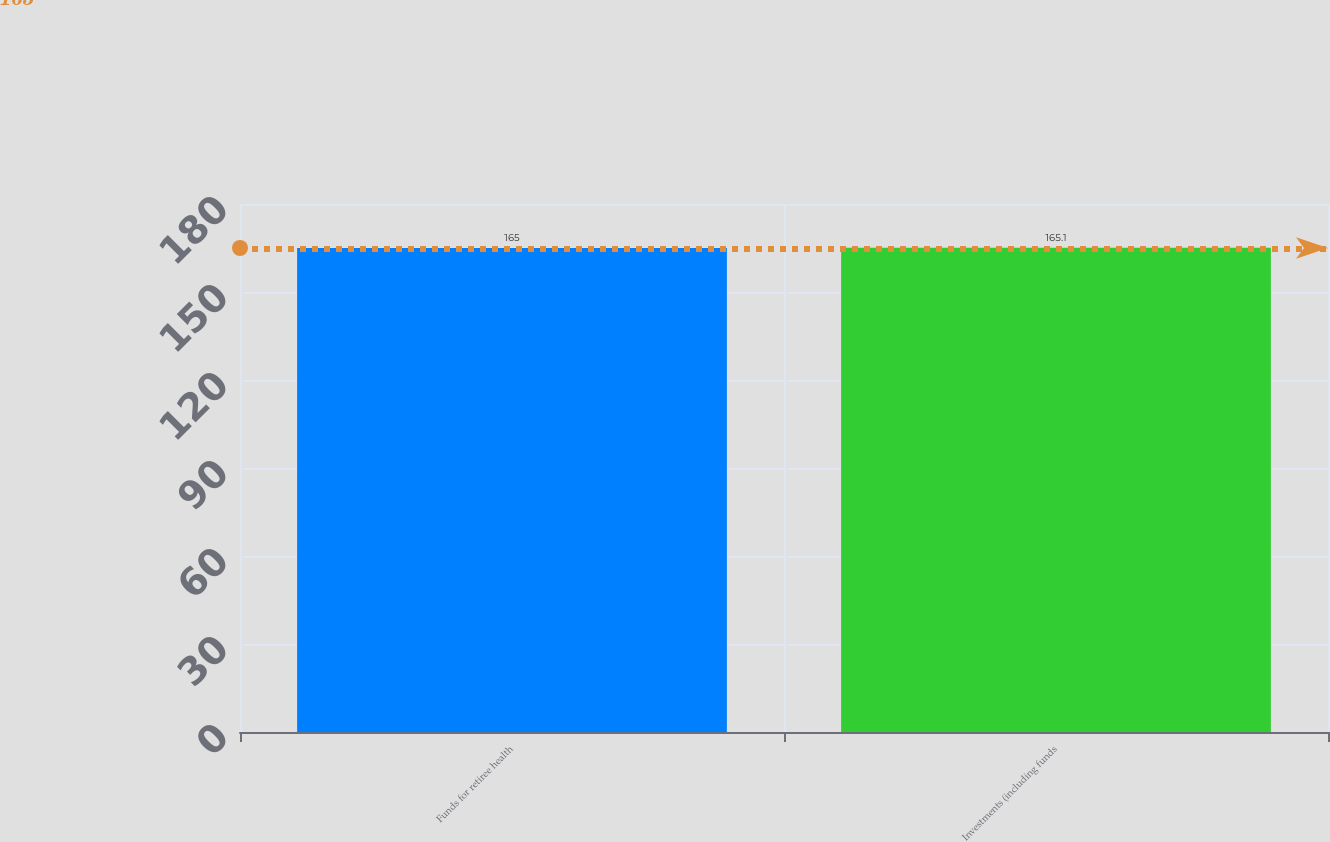Convert chart to OTSL. <chart><loc_0><loc_0><loc_500><loc_500><bar_chart><fcel>Funds for retiree health<fcel>Investments (including funds<nl><fcel>165<fcel>165.1<nl></chart> 